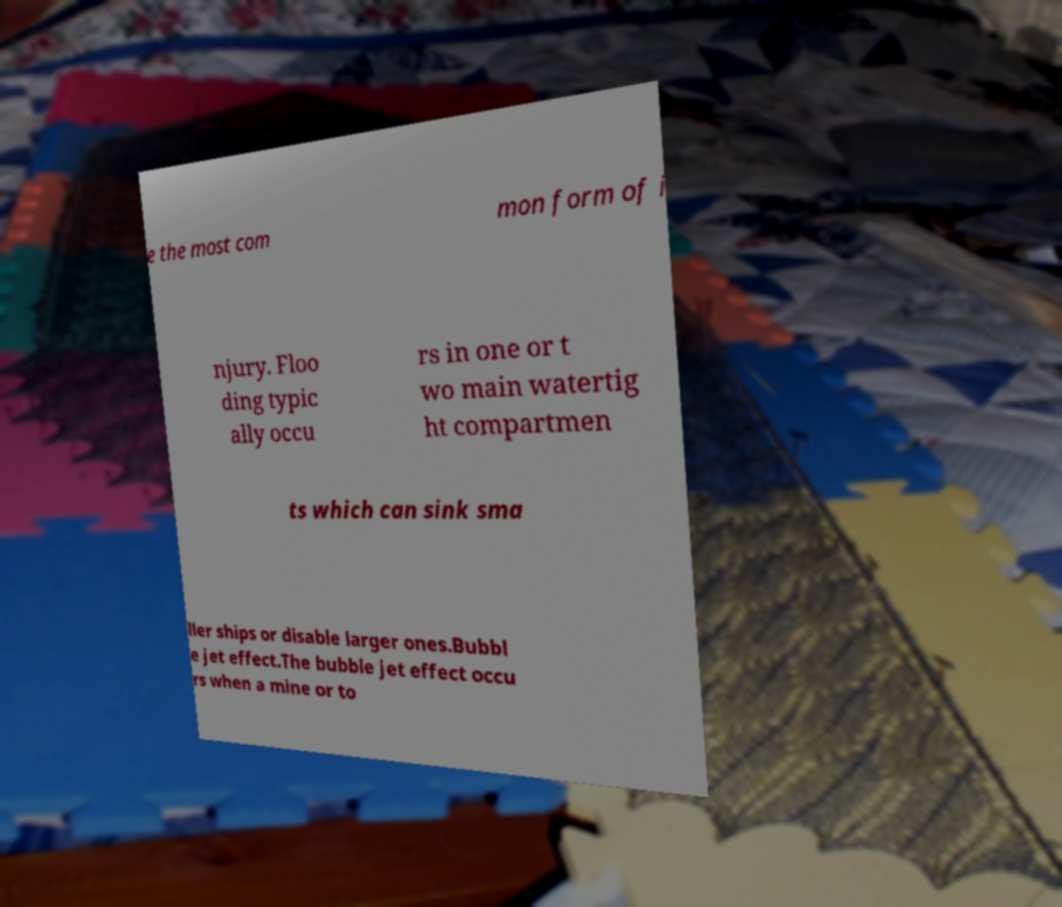Can you accurately transcribe the text from the provided image for me? e the most com mon form of i njury. Floo ding typic ally occu rs in one or t wo main watertig ht compartmen ts which can sink sma ller ships or disable larger ones.Bubbl e jet effect.The bubble jet effect occu rs when a mine or to 